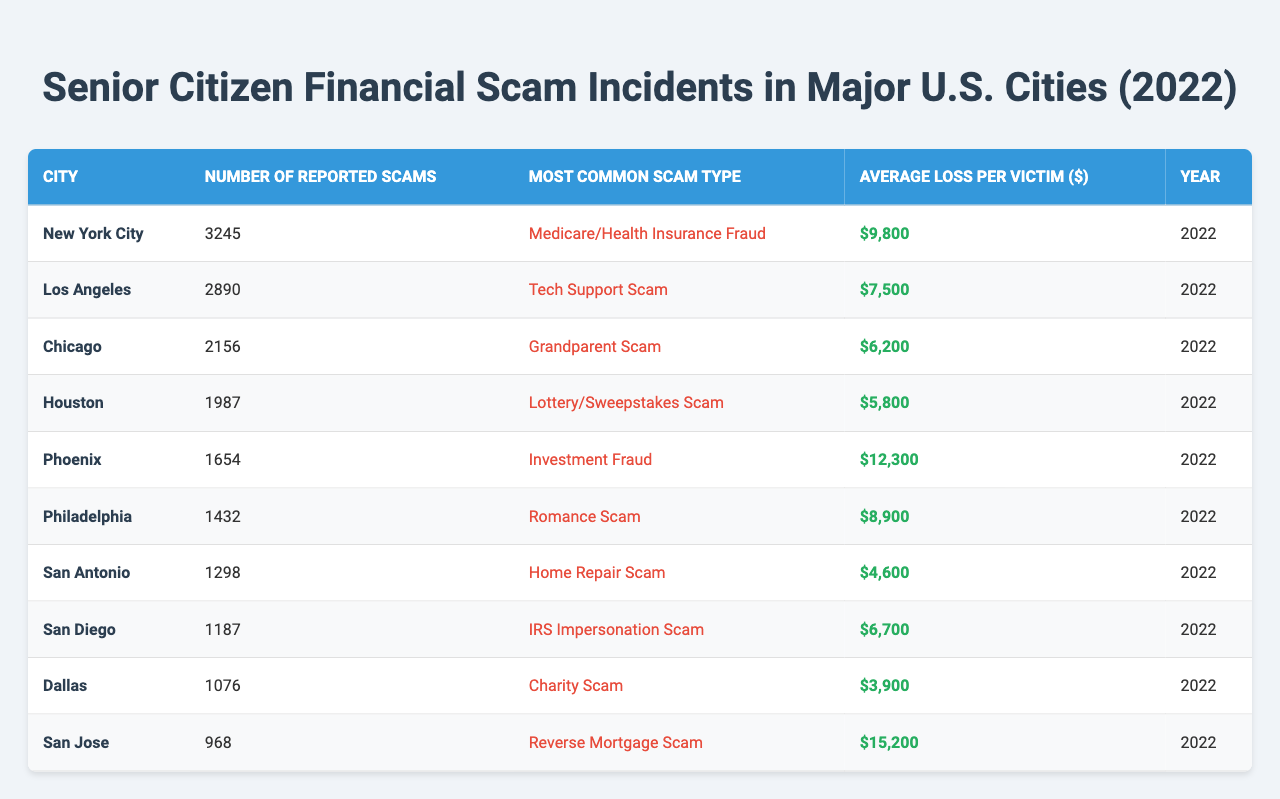What city reported the highest number of scams? By scanning through the "Number of Reported Scams" column, New York City has the highest value at 3,245.
Answer: New York City What is the average loss per victim for tech support scams? Looking in the "Most Common Scam Type" column, Los Angeles reported a tech support scam with an average loss of $7,500 per victim.
Answer: $7,500 Which city has the lowest number of reported scams? By reviewing the "Number of Reported Scams" column, San Jose has the lowest number at 968.
Answer: San Jose What type of scam caused the highest average loss per victim? The "Average Loss per Victim" column shows that the Reverse Mortgage Scam in San Jose has the highest average loss at $15,200.
Answer: Reverse Mortgage Scam How many more scams were reported in New York City compared to Dallas? Subtracting the number of reported scams in Dallas (1,076) from those in New York City (3,245) gives 3,245 - 1,076 = 2,169.
Answer: 2,169 What is the total number of reported scams across all cities? Adding the numbers from the "Number of Reported Scams" column gives a total of 3,245 + 2,890 + 2,156 + 1,987 + 1,654 + 1,432 + 1,298 + 1,187 + 1,076 + 968 = 18,072.
Answer: 18,072 Is the grandparent scam more common than the IRS impersonation scam? The "Most Common Scam Type" column indicates that the grandparent scam appears in Chicago while the IRS impersonation scam is in San Diego. Since both are listed, the answer is neither has a higher frequency as they belong to different cities.
Answer: No In which city did seniors lose on average the least amount of money per scam? By comparing the "Average Loss per Victim" column, San Antonio has the lowest average loss at $4,600.
Answer: San Antonio How many cities reported scams exceeding an average loss of $9,000 per victim? By reviewing the "Average Loss per Victim" column, the cities that exceed $9,000 are New York City ($9,800), Philadelphia ($8,900), and Phoenix ($12,300), which results in three cities.
Answer: 3 What is the most common scam type reported in Philadelphia? Referring to the "Most Common Scam Type" for Philadelphia, the scam type is Romance Scam.
Answer: Romance Scam 